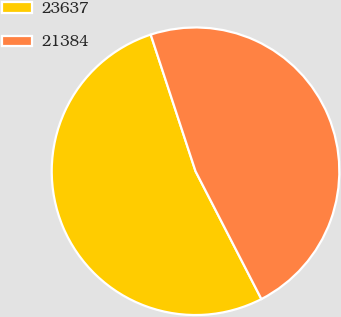<chart> <loc_0><loc_0><loc_500><loc_500><pie_chart><fcel>23637<fcel>21384<nl><fcel>52.53%<fcel>47.47%<nl></chart> 